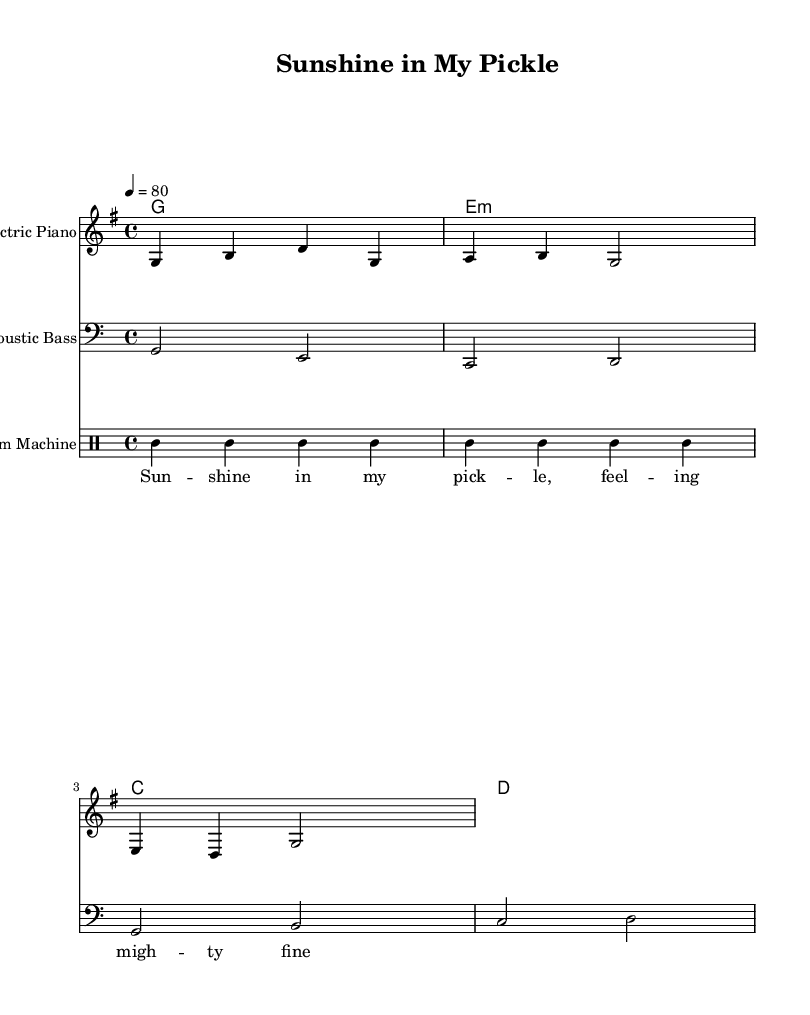What is the key signature of this music? The key signature is G major, which has one sharp (F#). The `\key g \major` directive indicates this.
Answer: G major What is the time signature of this piece? The time signature is 4/4, indicated by the `\time 4/4` directive. This means there are four beats in each measure.
Answer: 4/4 What is the tempo marking for the music? The tempo is marked as "4 = 80", which indicates that there are 80 quarter note beats per minute. This is found in the `\tempo` directive.
Answer: 80 What instrument plays the melody? The melody is assigned to the "Electric Piano", as indicated in the staff declaration with `instrumentName = "Electric Piano"`.
Answer: Electric Piano What type of message is conveyed through the lyrics? The lyrics convey a positive and uplifting message, with phrases like "Sunshine in my pickle, feeling mighty fine". This reflects the soothing and melodic style of the piece.
Answer: Positive What style of Hip Hop does this music represent? This music represents gentle, melodic Hip Hop, characterized by soothing instrumentals and positive messages, suitable for relaxation or uplifting moods.
Answer: Gentle melodic 